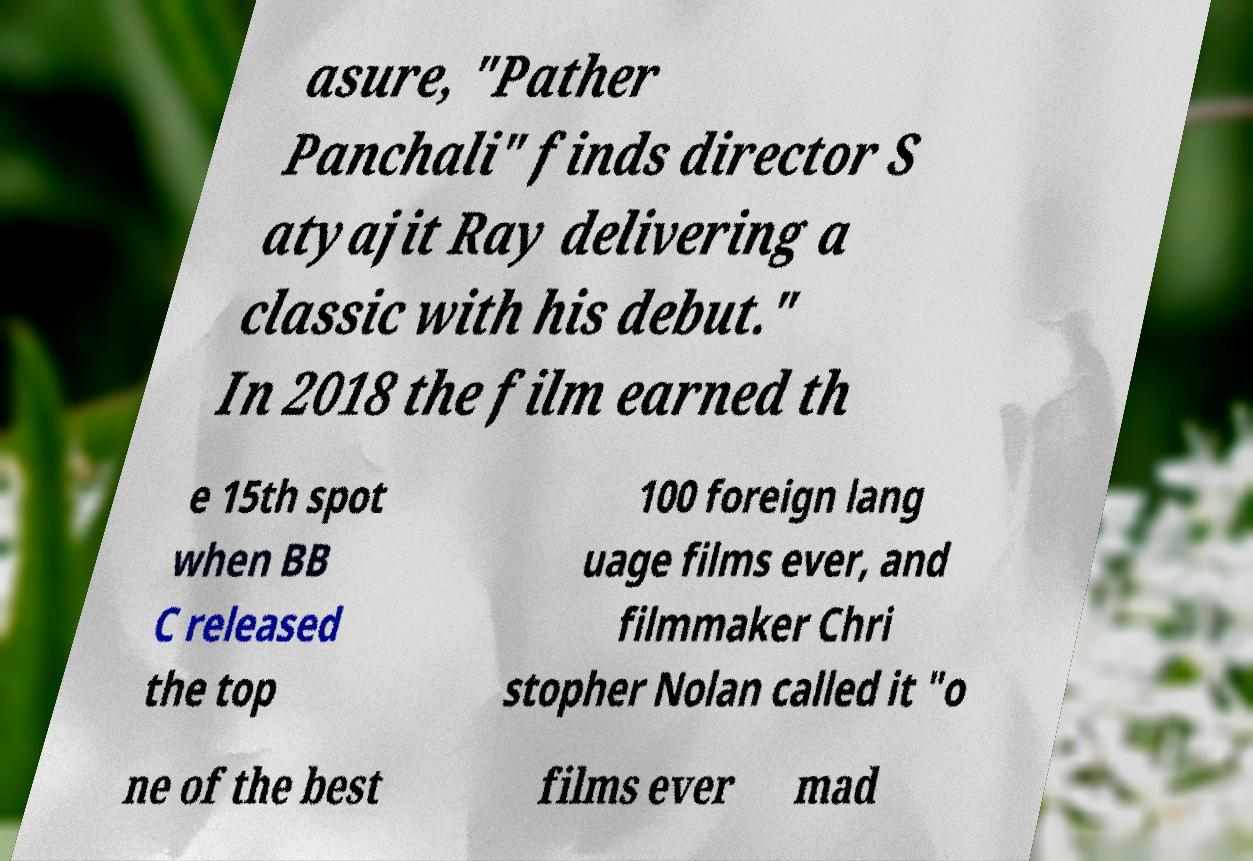Can you read and provide the text displayed in the image?This photo seems to have some interesting text. Can you extract and type it out for me? asure, "Pather Panchali" finds director S atyajit Ray delivering a classic with his debut." In 2018 the film earned th e 15th spot when BB C released the top 100 foreign lang uage films ever, and filmmaker Chri stopher Nolan called it "o ne of the best films ever mad 